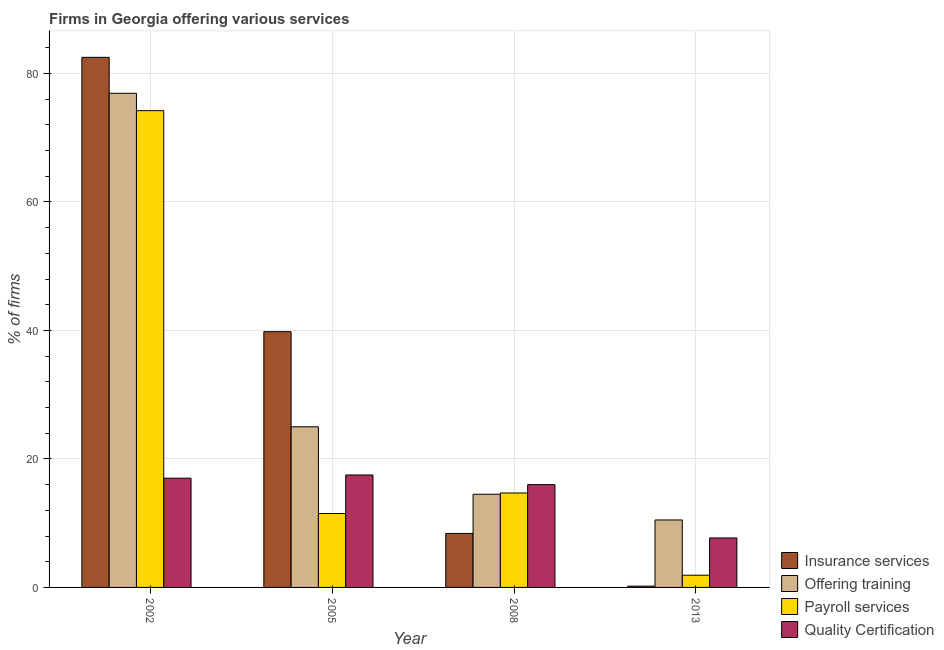Are the number of bars on each tick of the X-axis equal?
Provide a succinct answer. Yes. In how many cases, is the number of bars for a given year not equal to the number of legend labels?
Provide a succinct answer. 0. What is the percentage of firms offering quality certification in 2013?
Make the answer very short. 7.7. Across all years, what is the maximum percentage of firms offering training?
Offer a very short reply. 76.9. In which year was the percentage of firms offering training maximum?
Your response must be concise. 2002. In which year was the percentage of firms offering payroll services minimum?
Your answer should be very brief. 2013. What is the total percentage of firms offering quality certification in the graph?
Your response must be concise. 58.2. What is the difference between the percentage of firms offering insurance services in 2002 and that in 2013?
Offer a terse response. 82.3. What is the difference between the percentage of firms offering training in 2008 and the percentage of firms offering payroll services in 2005?
Your response must be concise. -10.5. What is the average percentage of firms offering payroll services per year?
Offer a terse response. 25.58. In the year 2005, what is the difference between the percentage of firms offering training and percentage of firms offering insurance services?
Give a very brief answer. 0. What is the ratio of the percentage of firms offering quality certification in 2008 to that in 2013?
Provide a succinct answer. 2.08. What is the difference between the highest and the lowest percentage of firms offering quality certification?
Offer a very short reply. 9.8. Is the sum of the percentage of firms offering quality certification in 2002 and 2005 greater than the maximum percentage of firms offering payroll services across all years?
Offer a terse response. Yes. What does the 4th bar from the left in 2005 represents?
Your answer should be very brief. Quality Certification. What does the 3rd bar from the right in 2002 represents?
Your answer should be very brief. Offering training. Is it the case that in every year, the sum of the percentage of firms offering insurance services and percentage of firms offering training is greater than the percentage of firms offering payroll services?
Offer a terse response. Yes. How many bars are there?
Your answer should be compact. 16. Does the graph contain grids?
Your response must be concise. Yes. Where does the legend appear in the graph?
Make the answer very short. Bottom right. How are the legend labels stacked?
Ensure brevity in your answer.  Vertical. What is the title of the graph?
Provide a short and direct response. Firms in Georgia offering various services . What is the label or title of the X-axis?
Make the answer very short. Year. What is the label or title of the Y-axis?
Your answer should be compact. % of firms. What is the % of firms in Insurance services in 2002?
Your response must be concise. 82.5. What is the % of firms of Offering training in 2002?
Keep it short and to the point. 76.9. What is the % of firms of Payroll services in 2002?
Provide a short and direct response. 74.2. What is the % of firms of Insurance services in 2005?
Your answer should be very brief. 39.8. What is the % of firms in Payroll services in 2005?
Offer a terse response. 11.5. What is the % of firms of Insurance services in 2008?
Your answer should be very brief. 8.4. What is the % of firms of Payroll services in 2008?
Your response must be concise. 14.7. What is the % of firms in Quality Certification in 2008?
Provide a short and direct response. 16. Across all years, what is the maximum % of firms of Insurance services?
Your response must be concise. 82.5. Across all years, what is the maximum % of firms in Offering training?
Provide a succinct answer. 76.9. Across all years, what is the maximum % of firms of Payroll services?
Your answer should be compact. 74.2. Across all years, what is the maximum % of firms in Quality Certification?
Give a very brief answer. 17.5. Across all years, what is the minimum % of firms in Insurance services?
Your response must be concise. 0.2. Across all years, what is the minimum % of firms of Offering training?
Provide a succinct answer. 10.5. Across all years, what is the minimum % of firms of Payroll services?
Ensure brevity in your answer.  1.9. What is the total % of firms of Insurance services in the graph?
Your answer should be compact. 130.9. What is the total % of firms in Offering training in the graph?
Your response must be concise. 126.9. What is the total % of firms of Payroll services in the graph?
Ensure brevity in your answer.  102.3. What is the total % of firms in Quality Certification in the graph?
Give a very brief answer. 58.2. What is the difference between the % of firms in Insurance services in 2002 and that in 2005?
Your response must be concise. 42.7. What is the difference between the % of firms of Offering training in 2002 and that in 2005?
Give a very brief answer. 51.9. What is the difference between the % of firms of Payroll services in 2002 and that in 2005?
Keep it short and to the point. 62.7. What is the difference between the % of firms of Insurance services in 2002 and that in 2008?
Provide a short and direct response. 74.1. What is the difference between the % of firms of Offering training in 2002 and that in 2008?
Make the answer very short. 62.4. What is the difference between the % of firms of Payroll services in 2002 and that in 2008?
Keep it short and to the point. 59.5. What is the difference between the % of firms of Quality Certification in 2002 and that in 2008?
Make the answer very short. 1. What is the difference between the % of firms of Insurance services in 2002 and that in 2013?
Offer a very short reply. 82.3. What is the difference between the % of firms in Offering training in 2002 and that in 2013?
Your answer should be compact. 66.4. What is the difference between the % of firms in Payroll services in 2002 and that in 2013?
Ensure brevity in your answer.  72.3. What is the difference between the % of firms in Insurance services in 2005 and that in 2008?
Give a very brief answer. 31.4. What is the difference between the % of firms in Payroll services in 2005 and that in 2008?
Your answer should be very brief. -3.2. What is the difference between the % of firms of Insurance services in 2005 and that in 2013?
Offer a very short reply. 39.6. What is the difference between the % of firms of Offering training in 2005 and that in 2013?
Ensure brevity in your answer.  14.5. What is the difference between the % of firms in Quality Certification in 2005 and that in 2013?
Your response must be concise. 9.8. What is the difference between the % of firms in Insurance services in 2008 and that in 2013?
Make the answer very short. 8.2. What is the difference between the % of firms of Insurance services in 2002 and the % of firms of Offering training in 2005?
Ensure brevity in your answer.  57.5. What is the difference between the % of firms of Insurance services in 2002 and the % of firms of Payroll services in 2005?
Give a very brief answer. 71. What is the difference between the % of firms of Insurance services in 2002 and the % of firms of Quality Certification in 2005?
Keep it short and to the point. 65. What is the difference between the % of firms of Offering training in 2002 and the % of firms of Payroll services in 2005?
Give a very brief answer. 65.4. What is the difference between the % of firms in Offering training in 2002 and the % of firms in Quality Certification in 2005?
Your answer should be very brief. 59.4. What is the difference between the % of firms of Payroll services in 2002 and the % of firms of Quality Certification in 2005?
Offer a terse response. 56.7. What is the difference between the % of firms of Insurance services in 2002 and the % of firms of Payroll services in 2008?
Your answer should be very brief. 67.8. What is the difference between the % of firms in Insurance services in 2002 and the % of firms in Quality Certification in 2008?
Provide a succinct answer. 66.5. What is the difference between the % of firms of Offering training in 2002 and the % of firms of Payroll services in 2008?
Your answer should be very brief. 62.2. What is the difference between the % of firms in Offering training in 2002 and the % of firms in Quality Certification in 2008?
Your answer should be compact. 60.9. What is the difference between the % of firms in Payroll services in 2002 and the % of firms in Quality Certification in 2008?
Your answer should be very brief. 58.2. What is the difference between the % of firms of Insurance services in 2002 and the % of firms of Offering training in 2013?
Your answer should be compact. 72. What is the difference between the % of firms in Insurance services in 2002 and the % of firms in Payroll services in 2013?
Give a very brief answer. 80.6. What is the difference between the % of firms in Insurance services in 2002 and the % of firms in Quality Certification in 2013?
Your answer should be compact. 74.8. What is the difference between the % of firms in Offering training in 2002 and the % of firms in Payroll services in 2013?
Offer a very short reply. 75. What is the difference between the % of firms of Offering training in 2002 and the % of firms of Quality Certification in 2013?
Provide a succinct answer. 69.2. What is the difference between the % of firms of Payroll services in 2002 and the % of firms of Quality Certification in 2013?
Provide a short and direct response. 66.5. What is the difference between the % of firms of Insurance services in 2005 and the % of firms of Offering training in 2008?
Offer a terse response. 25.3. What is the difference between the % of firms of Insurance services in 2005 and the % of firms of Payroll services in 2008?
Offer a terse response. 25.1. What is the difference between the % of firms of Insurance services in 2005 and the % of firms of Quality Certification in 2008?
Provide a succinct answer. 23.8. What is the difference between the % of firms of Offering training in 2005 and the % of firms of Payroll services in 2008?
Make the answer very short. 10.3. What is the difference between the % of firms of Insurance services in 2005 and the % of firms of Offering training in 2013?
Your response must be concise. 29.3. What is the difference between the % of firms of Insurance services in 2005 and the % of firms of Payroll services in 2013?
Provide a succinct answer. 37.9. What is the difference between the % of firms of Insurance services in 2005 and the % of firms of Quality Certification in 2013?
Provide a short and direct response. 32.1. What is the difference between the % of firms of Offering training in 2005 and the % of firms of Payroll services in 2013?
Offer a terse response. 23.1. What is the difference between the % of firms in Offering training in 2005 and the % of firms in Quality Certification in 2013?
Offer a terse response. 17.3. What is the difference between the % of firms of Payroll services in 2005 and the % of firms of Quality Certification in 2013?
Keep it short and to the point. 3.8. What is the difference between the % of firms of Insurance services in 2008 and the % of firms of Offering training in 2013?
Your answer should be very brief. -2.1. What is the difference between the % of firms of Insurance services in 2008 and the % of firms of Quality Certification in 2013?
Provide a short and direct response. 0.7. What is the difference between the % of firms of Offering training in 2008 and the % of firms of Payroll services in 2013?
Your answer should be compact. 12.6. What is the average % of firms in Insurance services per year?
Your answer should be compact. 32.73. What is the average % of firms of Offering training per year?
Give a very brief answer. 31.73. What is the average % of firms of Payroll services per year?
Your answer should be compact. 25.57. What is the average % of firms in Quality Certification per year?
Give a very brief answer. 14.55. In the year 2002, what is the difference between the % of firms in Insurance services and % of firms in Quality Certification?
Provide a short and direct response. 65.5. In the year 2002, what is the difference between the % of firms in Offering training and % of firms in Quality Certification?
Provide a succinct answer. 59.9. In the year 2002, what is the difference between the % of firms of Payroll services and % of firms of Quality Certification?
Make the answer very short. 57.2. In the year 2005, what is the difference between the % of firms in Insurance services and % of firms in Offering training?
Your answer should be very brief. 14.8. In the year 2005, what is the difference between the % of firms of Insurance services and % of firms of Payroll services?
Offer a terse response. 28.3. In the year 2005, what is the difference between the % of firms in Insurance services and % of firms in Quality Certification?
Ensure brevity in your answer.  22.3. In the year 2005, what is the difference between the % of firms in Payroll services and % of firms in Quality Certification?
Keep it short and to the point. -6. In the year 2008, what is the difference between the % of firms of Insurance services and % of firms of Payroll services?
Ensure brevity in your answer.  -6.3. In the year 2008, what is the difference between the % of firms in Insurance services and % of firms in Quality Certification?
Make the answer very short. -7.6. In the year 2008, what is the difference between the % of firms of Offering training and % of firms of Payroll services?
Your answer should be very brief. -0.2. In the year 2013, what is the difference between the % of firms in Insurance services and % of firms in Quality Certification?
Offer a terse response. -7.5. In the year 2013, what is the difference between the % of firms in Offering training and % of firms in Quality Certification?
Your answer should be compact. 2.8. What is the ratio of the % of firms in Insurance services in 2002 to that in 2005?
Make the answer very short. 2.07. What is the ratio of the % of firms of Offering training in 2002 to that in 2005?
Provide a short and direct response. 3.08. What is the ratio of the % of firms in Payroll services in 2002 to that in 2005?
Provide a succinct answer. 6.45. What is the ratio of the % of firms of Quality Certification in 2002 to that in 2005?
Your answer should be very brief. 0.97. What is the ratio of the % of firms in Insurance services in 2002 to that in 2008?
Make the answer very short. 9.82. What is the ratio of the % of firms of Offering training in 2002 to that in 2008?
Your response must be concise. 5.3. What is the ratio of the % of firms of Payroll services in 2002 to that in 2008?
Give a very brief answer. 5.05. What is the ratio of the % of firms in Insurance services in 2002 to that in 2013?
Make the answer very short. 412.5. What is the ratio of the % of firms of Offering training in 2002 to that in 2013?
Your answer should be very brief. 7.32. What is the ratio of the % of firms of Payroll services in 2002 to that in 2013?
Your response must be concise. 39.05. What is the ratio of the % of firms of Quality Certification in 2002 to that in 2013?
Ensure brevity in your answer.  2.21. What is the ratio of the % of firms of Insurance services in 2005 to that in 2008?
Ensure brevity in your answer.  4.74. What is the ratio of the % of firms in Offering training in 2005 to that in 2008?
Provide a succinct answer. 1.72. What is the ratio of the % of firms in Payroll services in 2005 to that in 2008?
Keep it short and to the point. 0.78. What is the ratio of the % of firms of Quality Certification in 2005 to that in 2008?
Ensure brevity in your answer.  1.09. What is the ratio of the % of firms in Insurance services in 2005 to that in 2013?
Offer a very short reply. 199. What is the ratio of the % of firms in Offering training in 2005 to that in 2013?
Offer a very short reply. 2.38. What is the ratio of the % of firms of Payroll services in 2005 to that in 2013?
Offer a very short reply. 6.05. What is the ratio of the % of firms of Quality Certification in 2005 to that in 2013?
Provide a succinct answer. 2.27. What is the ratio of the % of firms in Insurance services in 2008 to that in 2013?
Your answer should be compact. 42. What is the ratio of the % of firms of Offering training in 2008 to that in 2013?
Your answer should be very brief. 1.38. What is the ratio of the % of firms of Payroll services in 2008 to that in 2013?
Offer a terse response. 7.74. What is the ratio of the % of firms in Quality Certification in 2008 to that in 2013?
Your answer should be compact. 2.08. What is the difference between the highest and the second highest % of firms of Insurance services?
Your answer should be compact. 42.7. What is the difference between the highest and the second highest % of firms of Offering training?
Offer a very short reply. 51.9. What is the difference between the highest and the second highest % of firms of Payroll services?
Your answer should be very brief. 59.5. What is the difference between the highest and the lowest % of firms of Insurance services?
Offer a very short reply. 82.3. What is the difference between the highest and the lowest % of firms in Offering training?
Provide a short and direct response. 66.4. What is the difference between the highest and the lowest % of firms in Payroll services?
Make the answer very short. 72.3. 